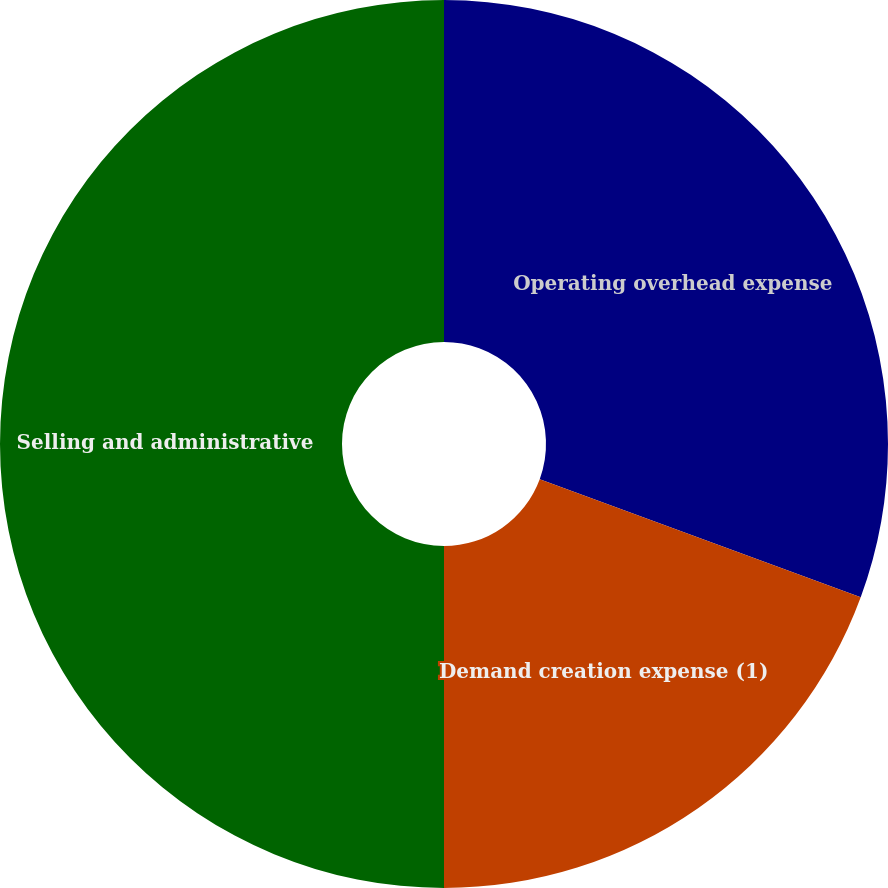Convert chart to OTSL. <chart><loc_0><loc_0><loc_500><loc_500><pie_chart><fcel>Operating overhead expense<fcel>Demand creation expense (1)<fcel>Selling and administrative<nl><fcel>30.61%<fcel>19.39%<fcel>50.0%<nl></chart> 